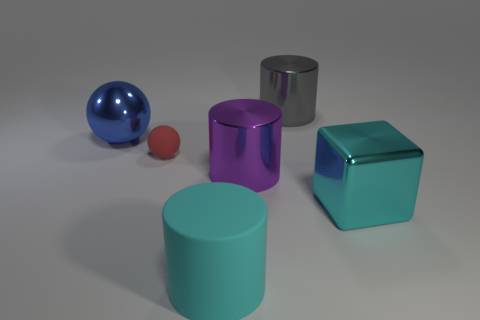Imagine if these objects started to interact like characters in a story. What might the cyan cylinder say to the silver cylinder? If the cyan cylinder were a character, it might say to the silver cylinder, 'Hello there, shiny friend! Isn't it a fine day to stand tall and be the centerpiece of this arrangement?' And how would the silver cylinder respond? 'Indeed, cyan companion! Though I must say, your vibrant hue brings a dash of cheer to our metallic and monochrome domain.' 